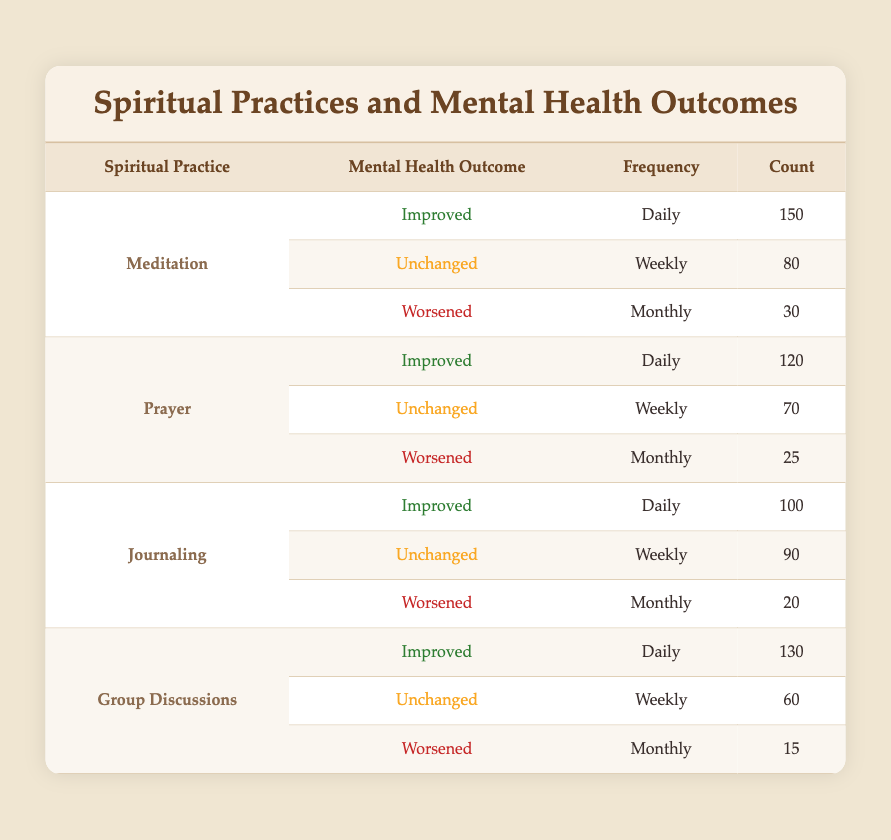What is the count of teenagers practicing meditation daily with improved mental health outcomes? From the table, under the meditation practice, the mental health outcome of improved shows a frequency of daily with a count of 150.
Answer: 150 How many teenagers report worsened mental health outcomes from journaling practices? According to the table, for journaling, there is a frequency of monthly with a count of 20 under the worsened mental health outcome.
Answer: 20 Which spiritual practice leads to the highest count of teenagers experiencing improved mental health outcomes daily? Reviewing the daily counts for improved mental health outcomes, meditation has 150, prayer has 120, journaling has 100, and group discussions have 130. Meditation has the highest count at 150.
Answer: Meditation What is the total count of teenagers who reported unchanged mental health outcomes across all spiritual practices weekly? The counts for unchanged mental health outcomes weekly are: meditation - 80, prayer - 70, journaling - 90, and group discussions - 60. Summing these counts gives: 80 + 70 + 90 + 60 = 300.
Answer: 300 Do more teenagers practice daily meditation than daily prayer with improved mental health outcomes? Comparing the counts for improved outcomes: daily meditation has 150 while daily prayer has 120. Since 150 is greater than 120, more teenagers practice daily meditation.
Answer: Yes Which spiritual practice had the lowest count of teenagers reporting worsened mental health outcomes? A comparison of the counts for worsened outcomes shows meditation has 30, prayer has 25, journaling has 20, and group discussions have 15. Group discussions have the lowest count at 15.
Answer: Group Discussions What percentage of teenagers practicing daily group discussions report improved mental health outcomes? There are 130 teenagers practicing daily group discussions with improved outcomes. To find the percentage, divide 130 by 130 (total of daily practices under Group Discussions) and then multiply by 100. This gives (130/130) * 100 = 100%.
Answer: 100% How does the frequency of journaling correlate with mental health outcomes among teenagers? Looking at the frequencies: daily shows 100 improved, weekly shows 90 unchanged, and monthly shows 20 worsened. Higher daily counts correspond to improved outcomes while monthly correlates with worsened outcomes, indicating a negative correlation with less frequency.
Answer: Negative correlation 